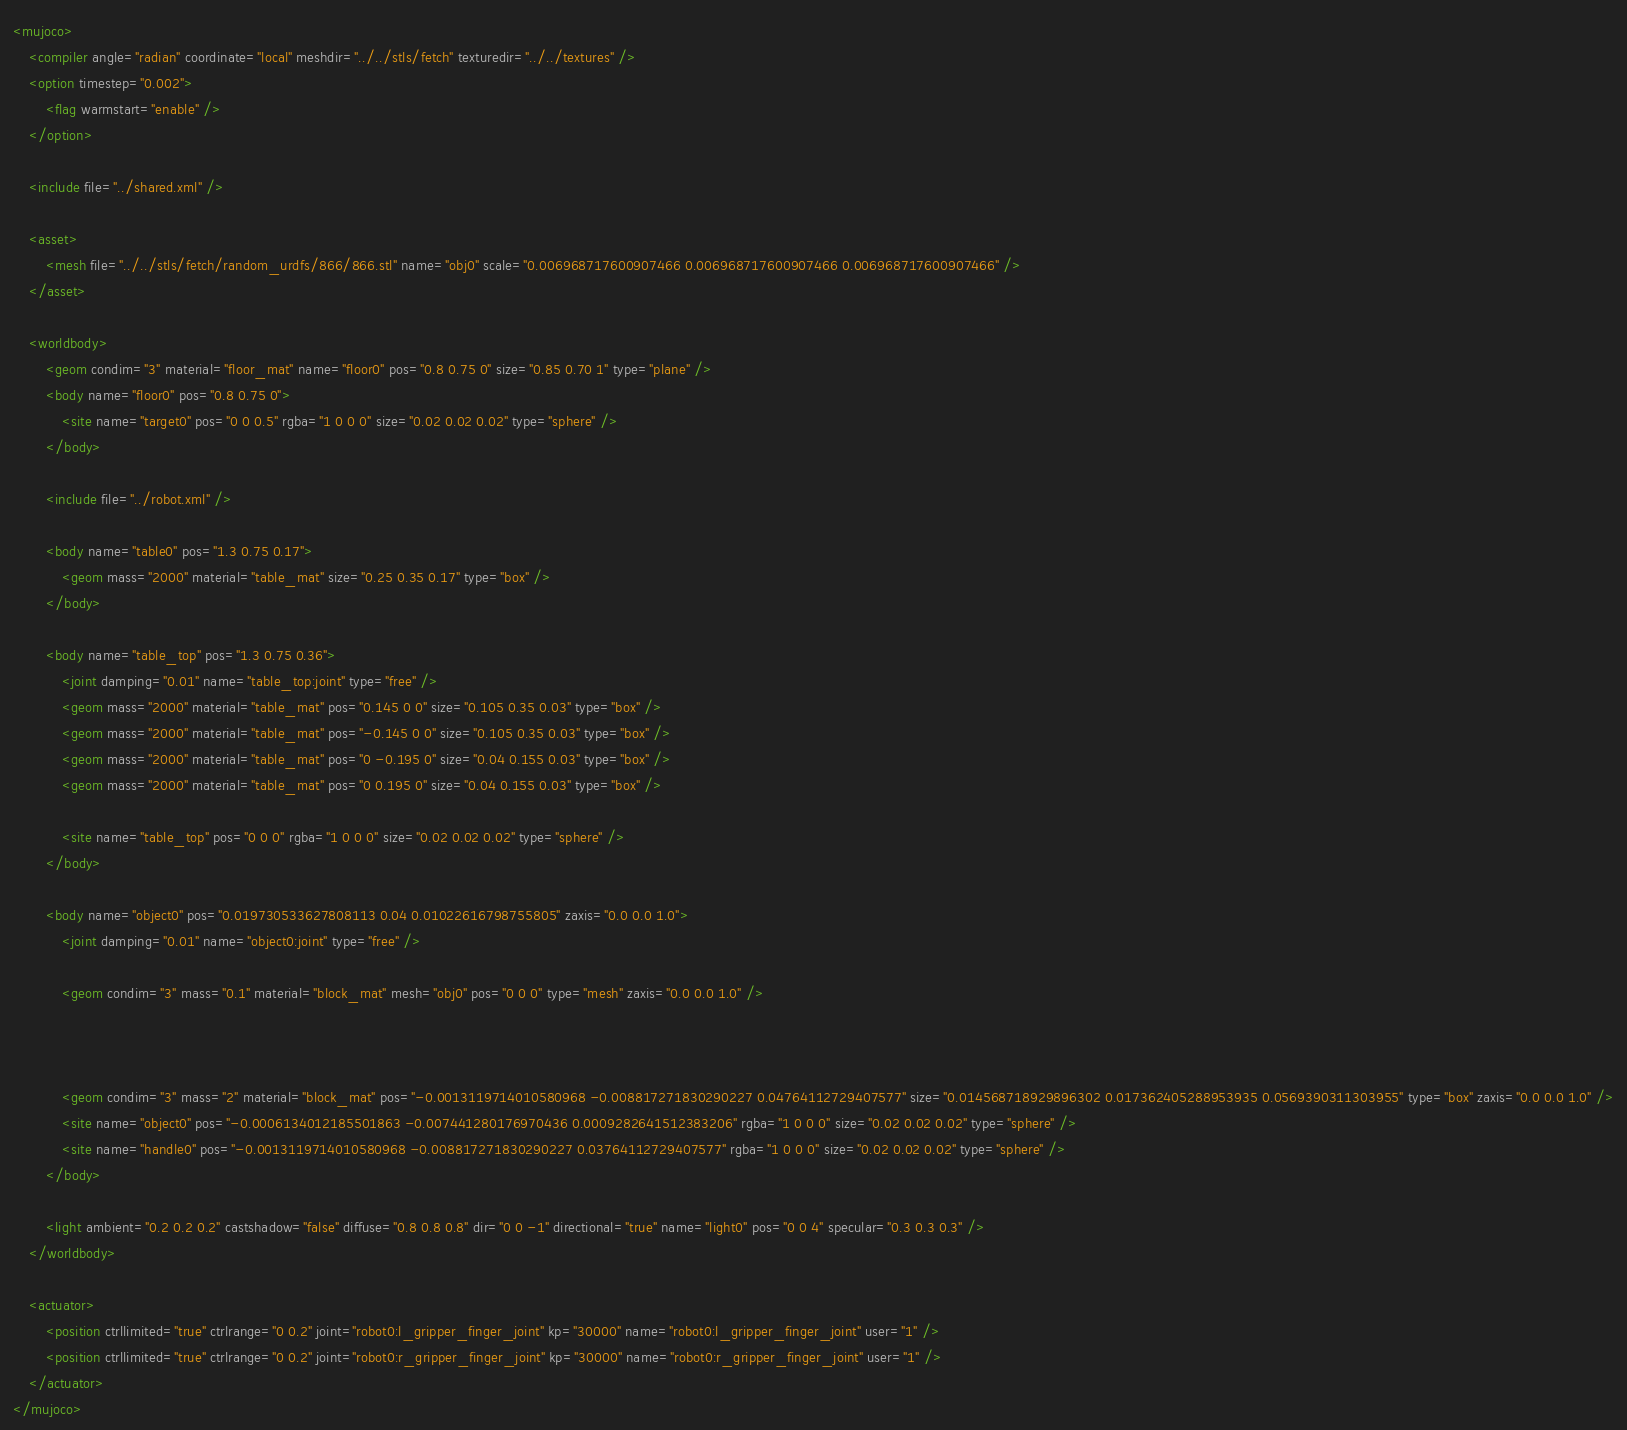Convert code to text. <code><loc_0><loc_0><loc_500><loc_500><_XML_><mujoco>
	<compiler angle="radian" coordinate="local" meshdir="../../stls/fetch" texturedir="../../textures" />
	<option timestep="0.002">
		<flag warmstart="enable" />
	</option>

	<include file="../shared.xml" />

	<asset>
		<mesh file="../../stls/fetch/random_urdfs/866/866.stl" name="obj0" scale="0.006968717600907466 0.006968717600907466 0.006968717600907466" />
	</asset>

	<worldbody>
		<geom condim="3" material="floor_mat" name="floor0" pos="0.8 0.75 0" size="0.85 0.70 1" type="plane" />
		<body name="floor0" pos="0.8 0.75 0">
			<site name="target0" pos="0 0 0.5" rgba="1 0 0 0" size="0.02 0.02 0.02" type="sphere" />
		</body>

		<include file="../robot.xml" />

		<body name="table0" pos="1.3 0.75 0.17">
			<geom mass="2000" material="table_mat" size="0.25 0.35 0.17" type="box" />
		</body>

		<body name="table_top" pos="1.3 0.75 0.36">
			<joint damping="0.01" name="table_top:joint" type="free" />
			<geom mass="2000" material="table_mat" pos="0.145 0 0" size="0.105 0.35 0.03" type="box" />
			<geom mass="2000" material="table_mat" pos="-0.145 0 0" size="0.105 0.35 0.03" type="box" />
			<geom mass="2000" material="table_mat" pos="0 -0.195 0" size="0.04 0.155 0.03" type="box" />
			<geom mass="2000" material="table_mat" pos="0 0.195 0" size="0.04 0.155 0.03" type="box" />

			<site name="table_top" pos="0 0 0" rgba="1 0 0 0" size="0.02 0.02 0.02" type="sphere" />
		</body>

		<body name="object0" pos="0.019730533627808113 0.04 0.01022616798755805" zaxis="0.0 0.0 1.0">
			<joint damping="0.01" name="object0:joint" type="free" />
			
			<geom condim="3" mass="0.1" material="block_mat" mesh="obj0" pos="0 0 0" type="mesh" zaxis="0.0 0.0 1.0" />
			
			
			
			<geom condim="3" mass="2" material="block_mat" pos="-0.0013119714010580968 -0.008817271830290227 0.04764112729407577" size="0.014568718929896302 0.017362405288953935 0.0569390311303955" type="box" zaxis="0.0 0.0 1.0" />
			<site name="object0" pos="-0.0006134012185501863 -0.007441280176970436 0.0009282641512383206" rgba="1 0 0 0" size="0.02 0.02 0.02" type="sphere" />
			<site name="handle0" pos="-0.0013119714010580968 -0.008817271830290227 0.03764112729407577" rgba="1 0 0 0" size="0.02 0.02 0.02" type="sphere" />
		</body>

		<light ambient="0.2 0.2 0.2" castshadow="false" diffuse="0.8 0.8 0.8" dir="0 0 -1" directional="true" name="light0" pos="0 0 4" specular="0.3 0.3 0.3" />
	</worldbody>

	<actuator>
		<position ctrllimited="true" ctrlrange="0 0.2" joint="robot0:l_gripper_finger_joint" kp="30000" name="robot0:l_gripper_finger_joint" user="1" />
		<position ctrllimited="true" ctrlrange="0 0.2" joint="robot0:r_gripper_finger_joint" kp="30000" name="robot0:r_gripper_finger_joint" user="1" />
	</actuator>
</mujoco></code> 